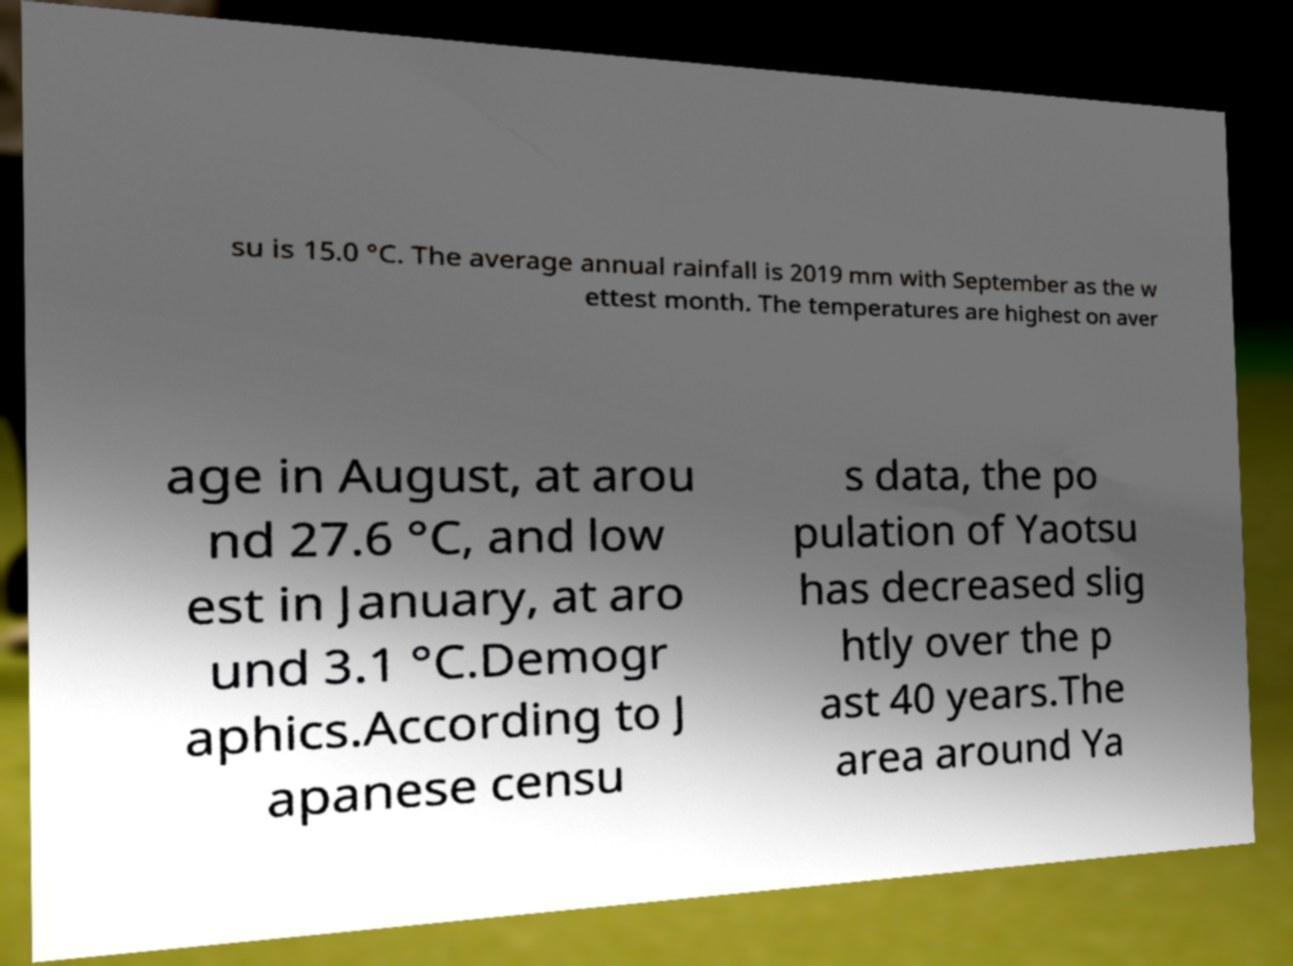I need the written content from this picture converted into text. Can you do that? su is 15.0 °C. The average annual rainfall is 2019 mm with September as the w ettest month. The temperatures are highest on aver age in August, at arou nd 27.6 °C, and low est in January, at aro und 3.1 °C.Demogr aphics.According to J apanese censu s data, the po pulation of Yaotsu has decreased slig htly over the p ast 40 years.The area around Ya 